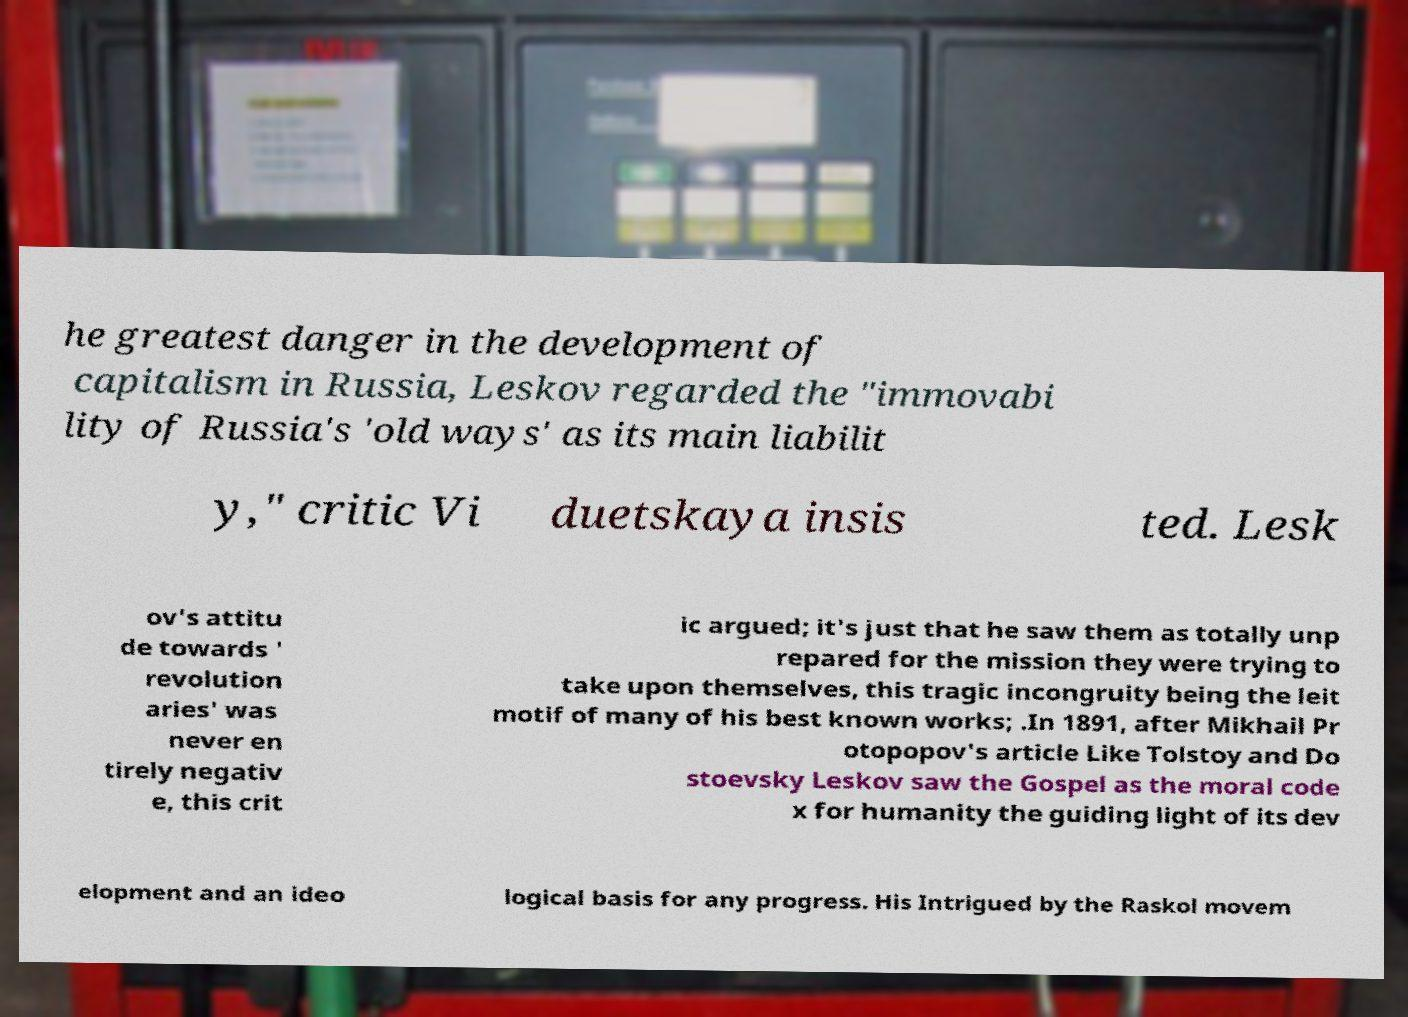I need the written content from this picture converted into text. Can you do that? he greatest danger in the development of capitalism in Russia, Leskov regarded the "immovabi lity of Russia's 'old ways' as its main liabilit y," critic Vi duetskaya insis ted. Lesk ov's attitu de towards ' revolution aries' was never en tirely negativ e, this crit ic argued; it's just that he saw them as totally unp repared for the mission they were trying to take upon themselves, this tragic incongruity being the leit motif of many of his best known works; .In 1891, after Mikhail Pr otopopov's article Like Tolstoy and Do stoevsky Leskov saw the Gospel as the moral code x for humanity the guiding light of its dev elopment and an ideo logical basis for any progress. His Intrigued by the Raskol movem 